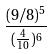Convert formula to latex. <formula><loc_0><loc_0><loc_500><loc_500>\frac { ( 9 / 8 ) ^ { 5 } } { ( \frac { 4 } { 1 0 } ) ^ { 6 } }</formula> 